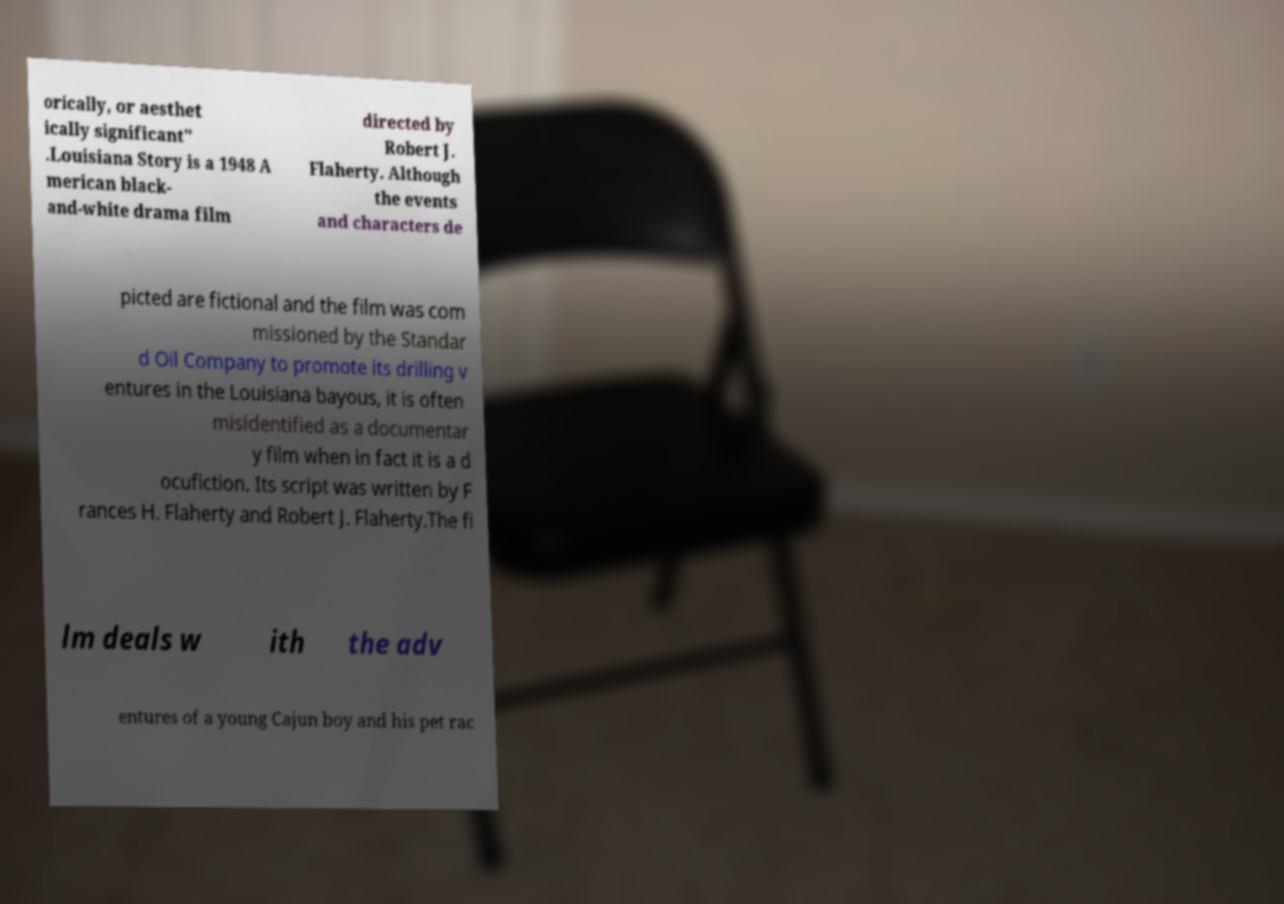There's text embedded in this image that I need extracted. Can you transcribe it verbatim? orically, or aesthet ically significant" .Louisiana Story is a 1948 A merican black- and-white drama film directed by Robert J. Flaherty. Although the events and characters de picted are fictional and the film was com missioned by the Standar d Oil Company to promote its drilling v entures in the Louisiana bayous, it is often misidentified as a documentar y film when in fact it is a d ocufiction. Its script was written by F rances H. Flaherty and Robert J. Flaherty.The fi lm deals w ith the adv entures of a young Cajun boy and his pet rac 